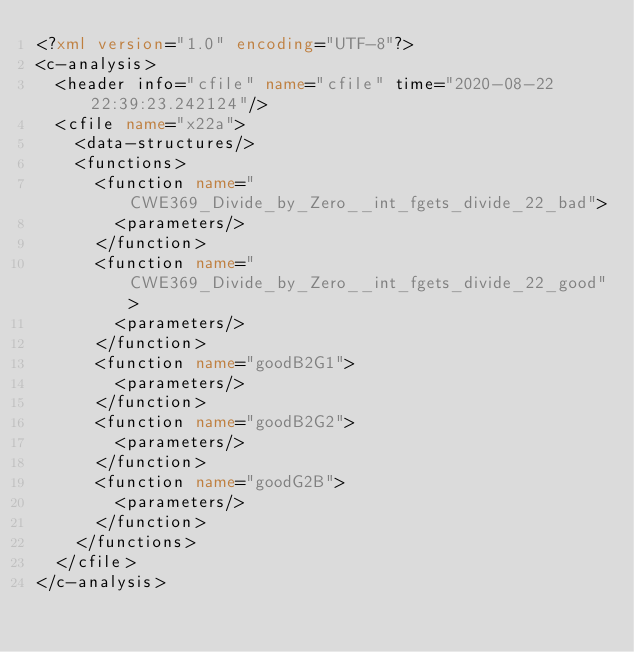Convert code to text. <code><loc_0><loc_0><loc_500><loc_500><_XML_><?xml version="1.0" encoding="UTF-8"?>
<c-analysis>
  <header info="cfile" name="cfile" time="2020-08-22 22:39:23.242124"/>
  <cfile name="x22a">
    <data-structures/>
    <functions>
      <function name="CWE369_Divide_by_Zero__int_fgets_divide_22_bad">
        <parameters/>
      </function>
      <function name="CWE369_Divide_by_Zero__int_fgets_divide_22_good">
        <parameters/>
      </function>
      <function name="goodB2G1">
        <parameters/>
      </function>
      <function name="goodB2G2">
        <parameters/>
      </function>
      <function name="goodG2B">
        <parameters/>
      </function>
    </functions>
  </cfile>
</c-analysis>
</code> 